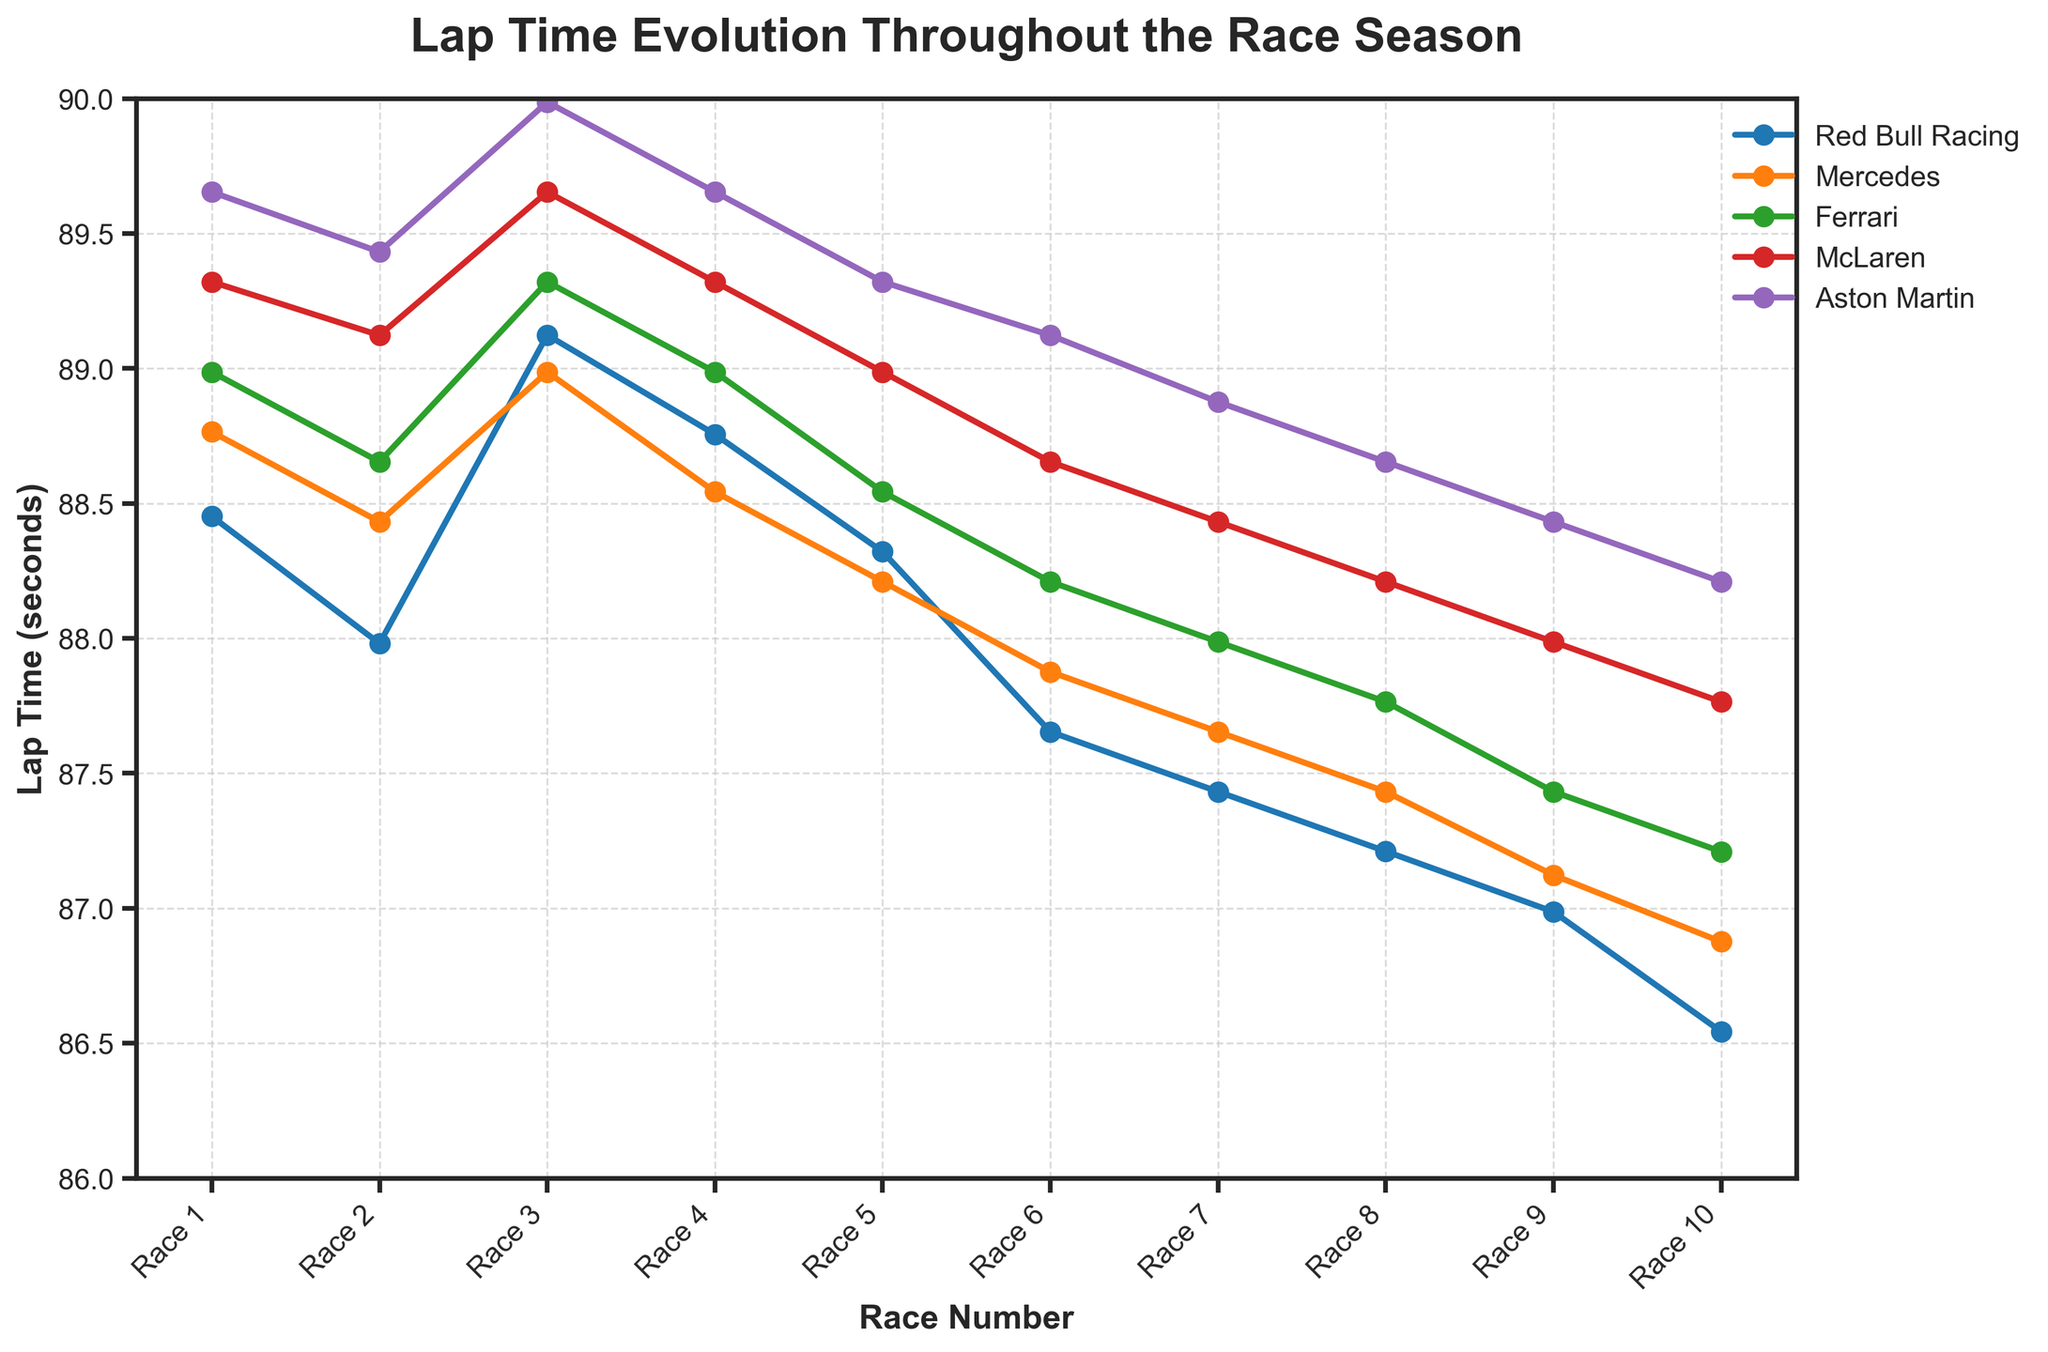What is the trend in lap times for Red Bull Racing over the 10 races? By looking at the plot for Red Bull Racing, we observe a general decreasing trend in lap times, indicating an improvement in performance over the season. The lap times start at 88.452 seconds in Race 1 and drop to 86.543 seconds in Race 10.
Answer: Decreasing Which team has the lowest lap time in Race 5? Observing the lap times for all teams in Race 5, Red Bull Racing has the lowest lap time at 88.321 seconds.
Answer: Red Bull Racing Between Mercedes and Ferrari, which team shows more consistent performance in terms of lap times, and how can you tell? By comparing the lap time lines for Mercedes and Ferrari, we observe that Mercedes' lap times have smaller fluctuations compared to Ferrari's lap times, indicating more consistency.
Answer: Mercedes How much did McLaren’s lap time improve from Race 1 to Race 10? McLaren's lap time was 89.321 seconds in Race 1 and improved to 87.765 seconds in Race 10. The improvement can be calculated by subtracting the Race 10 time from the Race 1 time: 89.321 - 87.765 = 1.556 seconds.
Answer: 1.556 seconds Rank the teams based on their lap times in Race 7 from fastest to slowest. From the plot for Race 7, the lap times are as follows: Red Bull Racing (87.432), Mercedes (87.654), Ferrari (87.987), McLaren (88.432), and Aston Martin (88.876). Thus, the ranking is: Red Bull Racing, Mercedes, Ferrari, McLaren, Aston Martin.
Answer: Red Bull Racing, Mercedes, Ferrari, McLaren, Aston Martin On which race did Ferrari achieve their best lap time, and what was that lap time? By observing the plot for Ferrari, their best lap time is 87.210 seconds, achieved in Race 10.
Answer: Race 10, 87.210 seconds Compare the lap times of Aston Martin in Race 1 and Race 10. How much did their lap time change? In Race 1, Aston Martin's lap time was 89.654 seconds, and in Race 10, it was 88.210 seconds. The change is calculated as: 89.654 - 88.210 = 1.444 seconds.
Answer: 1.444 seconds Which team had the smallest variation in lap times across all races, and how can you determine that? By visually comparing the plots, Red Bull Racing’s lap times have the least variation, consistently converging with minimal fluctuation throughout the races.
Answer: Red Bull Racing What can be inferred about McLaren’s performance trend from Race 3 to Race 8? Observing McLaren’s lap times from Race 3 to Race 8, we see a gradual decreasing trend from 89.654 seconds to 88.210 seconds, indicating a consistent improvement over these races.
Answer: Improvement 